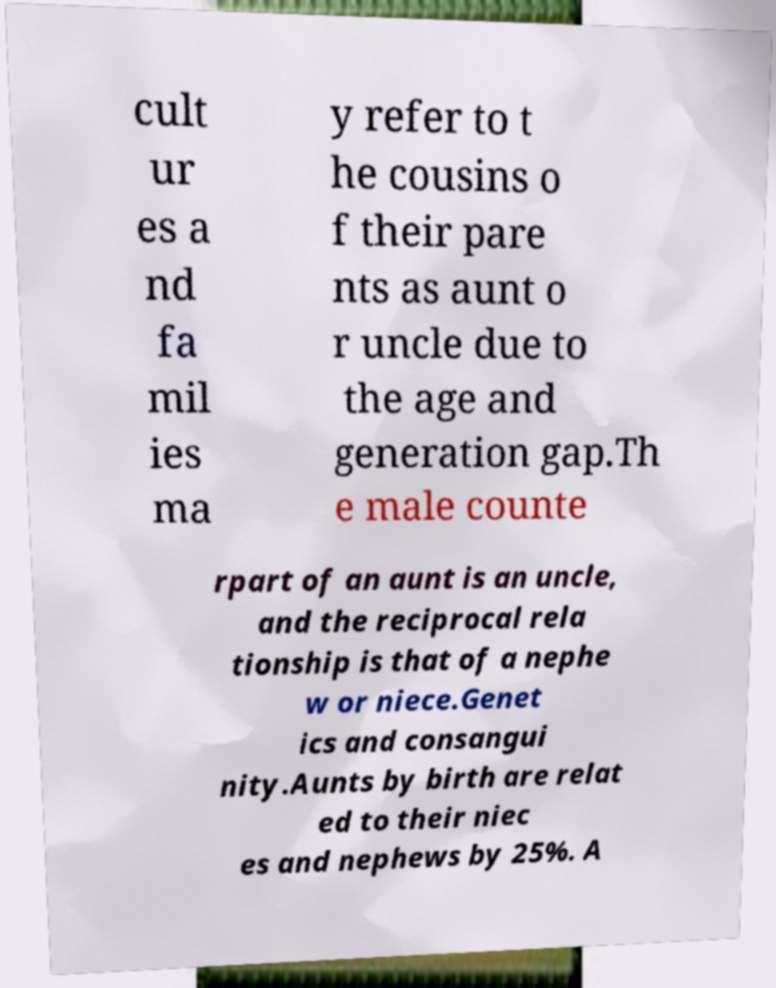Can you accurately transcribe the text from the provided image for me? cult ur es a nd fa mil ies ma y refer to t he cousins o f their pare nts as aunt o r uncle due to the age and generation gap.Th e male counte rpart of an aunt is an uncle, and the reciprocal rela tionship is that of a nephe w or niece.Genet ics and consangui nity.Aunts by birth are relat ed to their niec es and nephews by 25%. A 